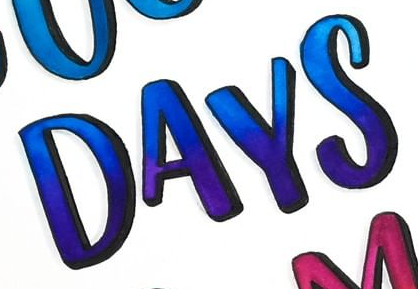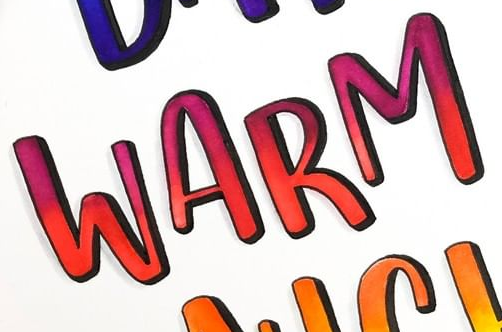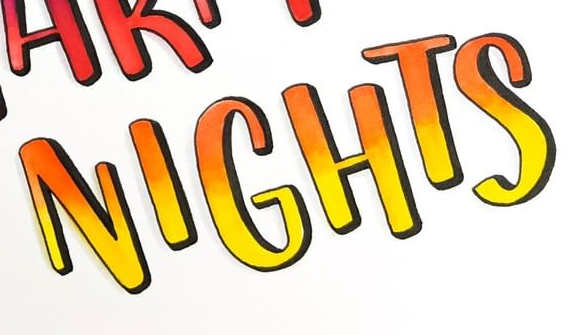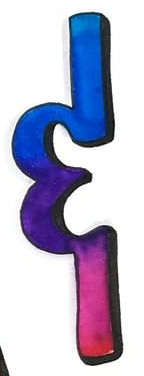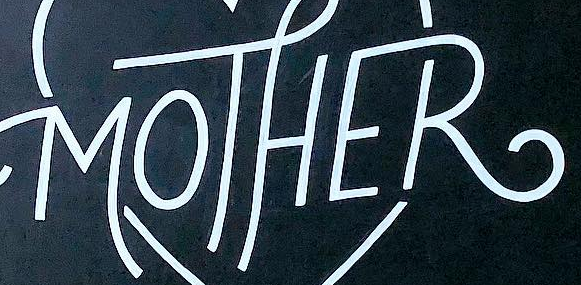What words can you see in these images in sequence, separated by a semicolon? DAYS; WARM; NIGHTS; &; MOTHER 